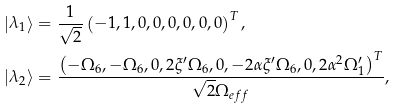<formula> <loc_0><loc_0><loc_500><loc_500>\left | \lambda _ { 1 } \right \rangle & = \frac { 1 } { \sqrt { 2 } } \left ( - 1 , 1 , 0 , 0 , 0 , 0 , 0 , 0 \right ) ^ { T } , \\ \left | \lambda _ { 2 } \right \rangle & = \frac { \left ( - \Omega _ { 6 } , - \Omega _ { 6 } , 0 , 2 \xi ^ { \prime } \Omega _ { 6 } , 0 , - 2 \alpha \xi ^ { \prime } \Omega _ { 6 } , 0 , 2 \alpha ^ { 2 } \Omega _ { 1 } ^ { \prime } \right ) ^ { T } } { \sqrt { 2 } \Omega _ { e f f } } ,</formula> 